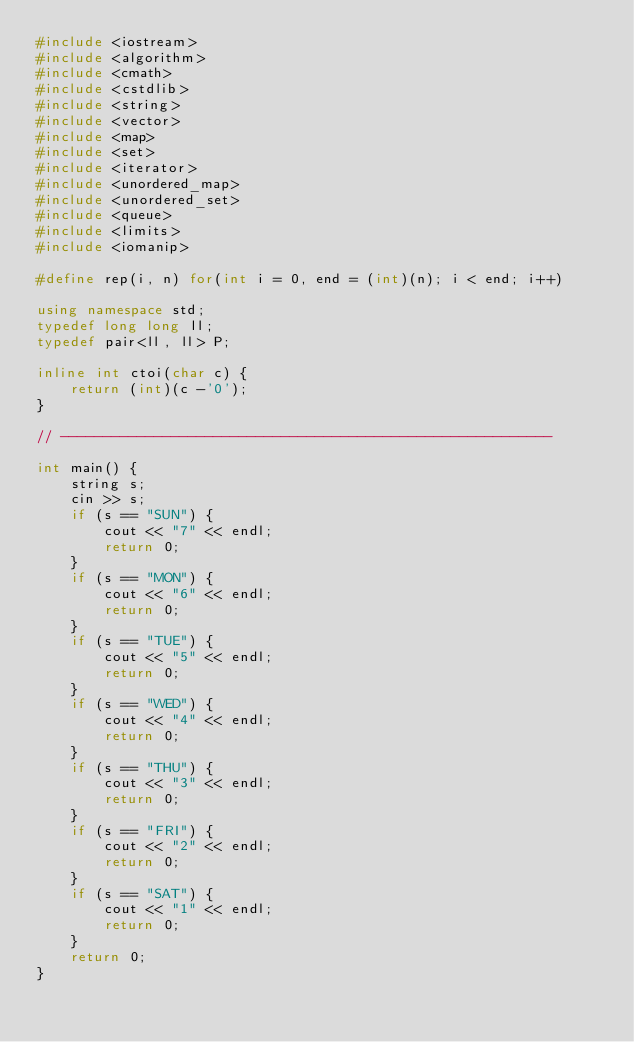Convert code to text. <code><loc_0><loc_0><loc_500><loc_500><_C++_>#include <iostream>
#include <algorithm>
#include <cmath>
#include <cstdlib>
#include <string>
#include <vector>
#include <map>
#include <set>
#include <iterator>
#include <unordered_map>
#include <unordered_set>
#include <queue>
#include <limits>
#include <iomanip>

#define rep(i, n) for(int i = 0, end = (int)(n); i < end; i++)

using namespace std;
typedef long long ll;
typedef pair<ll, ll> P;

inline int ctoi(char c) {
    return (int)(c -'0');
}

// ----------------------------------------------------------

int main() {
    string s;
    cin >> s;
    if (s == "SUN") {
        cout << "7" << endl;
        return 0;
    }
    if (s == "MON") {
        cout << "6" << endl;
        return 0;
    }
    if (s == "TUE") {
        cout << "5" << endl;
        return 0;
    }
    if (s == "WED") {
        cout << "4" << endl;
        return 0;
    }
    if (s == "THU") {
        cout << "3" << endl;
        return 0;
    }
    if (s == "FRI") {
        cout << "2" << endl;
        return 0;
    }
    if (s == "SAT") {
        cout << "1" << endl;
        return 0;
    }
    return 0;
}
</code> 